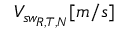Convert formula to latex. <formula><loc_0><loc_0><loc_500><loc_500>V _ { s w _ { R , T , N } } [ m / s ]</formula> 